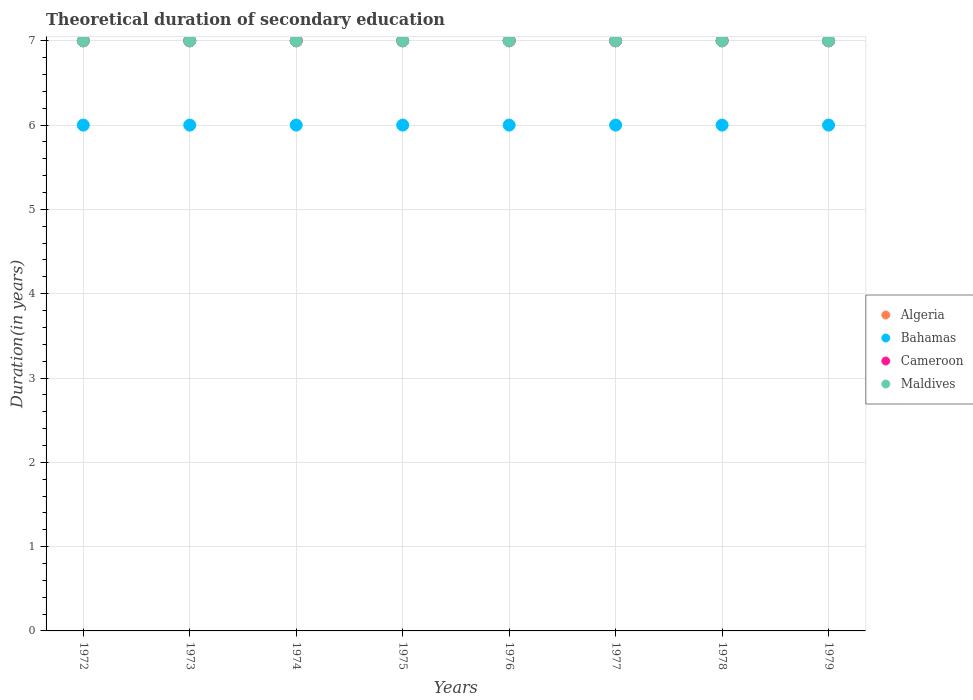How many different coloured dotlines are there?
Provide a short and direct response. 4. Is the number of dotlines equal to the number of legend labels?
Keep it short and to the point. Yes. What is the total theoretical duration of secondary education in Cameroon in 1975?
Offer a terse response. 7. Across all years, what is the maximum total theoretical duration of secondary education in Bahamas?
Offer a very short reply. 6. Across all years, what is the minimum total theoretical duration of secondary education in Cameroon?
Provide a short and direct response. 7. In which year was the total theoretical duration of secondary education in Algeria maximum?
Offer a terse response. 1972. In which year was the total theoretical duration of secondary education in Algeria minimum?
Provide a succinct answer. 1972. What is the total total theoretical duration of secondary education in Algeria in the graph?
Provide a short and direct response. 56. What is the difference between the total theoretical duration of secondary education in Cameroon in 1979 and the total theoretical duration of secondary education in Algeria in 1977?
Make the answer very short. 0. What is the average total theoretical duration of secondary education in Maldives per year?
Your response must be concise. 7. In the year 1979, what is the difference between the total theoretical duration of secondary education in Cameroon and total theoretical duration of secondary education in Maldives?
Make the answer very short. 0. In how many years, is the total theoretical duration of secondary education in Bahamas greater than 4.6 years?
Offer a very short reply. 8. What is the ratio of the total theoretical duration of secondary education in Cameroon in 1973 to that in 1979?
Your response must be concise. 1. Is the total theoretical duration of secondary education in Bahamas in 1973 less than that in 1976?
Your response must be concise. No. What is the difference between the highest and the second highest total theoretical duration of secondary education in Bahamas?
Your answer should be very brief. 0. What is the difference between the highest and the lowest total theoretical duration of secondary education in Bahamas?
Ensure brevity in your answer.  0. Is it the case that in every year, the sum of the total theoretical duration of secondary education in Bahamas and total theoretical duration of secondary education in Cameroon  is greater than the sum of total theoretical duration of secondary education in Maldives and total theoretical duration of secondary education in Algeria?
Make the answer very short. No. Does the total theoretical duration of secondary education in Maldives monotonically increase over the years?
Keep it short and to the point. No. How many dotlines are there?
Keep it short and to the point. 4. Does the graph contain grids?
Provide a succinct answer. Yes. Where does the legend appear in the graph?
Provide a short and direct response. Center right. How many legend labels are there?
Give a very brief answer. 4. How are the legend labels stacked?
Your answer should be compact. Vertical. What is the title of the graph?
Give a very brief answer. Theoretical duration of secondary education. What is the label or title of the Y-axis?
Your answer should be very brief. Duration(in years). What is the Duration(in years) in Bahamas in 1972?
Your answer should be compact. 6. What is the Duration(in years) of Cameroon in 1972?
Provide a succinct answer. 7. What is the Duration(in years) of Maldives in 1972?
Your answer should be very brief. 7. What is the Duration(in years) of Algeria in 1973?
Provide a short and direct response. 7. What is the Duration(in years) in Maldives in 1973?
Ensure brevity in your answer.  7. What is the Duration(in years) of Algeria in 1974?
Your answer should be compact. 7. What is the Duration(in years) in Bahamas in 1974?
Offer a very short reply. 6. What is the Duration(in years) in Maldives in 1974?
Your answer should be compact. 7. What is the Duration(in years) in Algeria in 1975?
Give a very brief answer. 7. What is the Duration(in years) of Cameroon in 1975?
Your response must be concise. 7. What is the Duration(in years) in Bahamas in 1976?
Give a very brief answer. 6. What is the Duration(in years) of Cameroon in 1976?
Give a very brief answer. 7. What is the Duration(in years) in Algeria in 1977?
Make the answer very short. 7. What is the Duration(in years) of Bahamas in 1977?
Offer a very short reply. 6. What is the Duration(in years) in Bahamas in 1978?
Give a very brief answer. 6. What is the Duration(in years) in Cameroon in 1978?
Provide a succinct answer. 7. What is the Duration(in years) in Algeria in 1979?
Keep it short and to the point. 7. What is the Duration(in years) in Bahamas in 1979?
Your response must be concise. 6. What is the Duration(in years) in Cameroon in 1979?
Make the answer very short. 7. What is the Duration(in years) of Maldives in 1979?
Ensure brevity in your answer.  7. Across all years, what is the maximum Duration(in years) in Algeria?
Provide a short and direct response. 7. Across all years, what is the maximum Duration(in years) of Bahamas?
Your answer should be very brief. 6. Across all years, what is the minimum Duration(in years) in Algeria?
Provide a succinct answer. 7. Across all years, what is the minimum Duration(in years) in Cameroon?
Provide a short and direct response. 7. What is the total Duration(in years) in Cameroon in the graph?
Your response must be concise. 56. What is the difference between the Duration(in years) in Algeria in 1972 and that in 1974?
Provide a succinct answer. 0. What is the difference between the Duration(in years) of Cameroon in 1972 and that in 1974?
Give a very brief answer. 0. What is the difference between the Duration(in years) in Maldives in 1972 and that in 1974?
Your answer should be compact. 0. What is the difference between the Duration(in years) in Algeria in 1972 and that in 1975?
Give a very brief answer. 0. What is the difference between the Duration(in years) of Cameroon in 1972 and that in 1975?
Offer a very short reply. 0. What is the difference between the Duration(in years) of Algeria in 1972 and that in 1976?
Provide a succinct answer. 0. What is the difference between the Duration(in years) in Cameroon in 1972 and that in 1976?
Ensure brevity in your answer.  0. What is the difference between the Duration(in years) of Maldives in 1972 and that in 1976?
Your answer should be compact. 0. What is the difference between the Duration(in years) in Algeria in 1972 and that in 1977?
Your answer should be compact. 0. What is the difference between the Duration(in years) of Cameroon in 1972 and that in 1977?
Give a very brief answer. 0. What is the difference between the Duration(in years) of Maldives in 1972 and that in 1977?
Ensure brevity in your answer.  0. What is the difference between the Duration(in years) of Cameroon in 1972 and that in 1978?
Give a very brief answer. 0. What is the difference between the Duration(in years) in Cameroon in 1972 and that in 1979?
Keep it short and to the point. 0. What is the difference between the Duration(in years) of Algeria in 1973 and that in 1974?
Offer a terse response. 0. What is the difference between the Duration(in years) in Maldives in 1973 and that in 1974?
Ensure brevity in your answer.  0. What is the difference between the Duration(in years) in Bahamas in 1973 and that in 1975?
Keep it short and to the point. 0. What is the difference between the Duration(in years) in Cameroon in 1973 and that in 1975?
Offer a very short reply. 0. What is the difference between the Duration(in years) in Algeria in 1973 and that in 1976?
Your answer should be very brief. 0. What is the difference between the Duration(in years) of Bahamas in 1973 and that in 1976?
Offer a terse response. 0. What is the difference between the Duration(in years) in Maldives in 1973 and that in 1976?
Keep it short and to the point. 0. What is the difference between the Duration(in years) of Algeria in 1973 and that in 1977?
Provide a short and direct response. 0. What is the difference between the Duration(in years) of Cameroon in 1973 and that in 1977?
Offer a terse response. 0. What is the difference between the Duration(in years) in Algeria in 1973 and that in 1978?
Give a very brief answer. 0. What is the difference between the Duration(in years) of Bahamas in 1973 and that in 1978?
Offer a terse response. 0. What is the difference between the Duration(in years) of Cameroon in 1973 and that in 1978?
Your answer should be compact. 0. What is the difference between the Duration(in years) in Maldives in 1973 and that in 1978?
Provide a succinct answer. 0. What is the difference between the Duration(in years) of Algeria in 1973 and that in 1979?
Provide a succinct answer. 0. What is the difference between the Duration(in years) of Bahamas in 1973 and that in 1979?
Your response must be concise. 0. What is the difference between the Duration(in years) of Cameroon in 1973 and that in 1979?
Your response must be concise. 0. What is the difference between the Duration(in years) of Maldives in 1973 and that in 1979?
Offer a very short reply. 0. What is the difference between the Duration(in years) in Algeria in 1974 and that in 1975?
Your response must be concise. 0. What is the difference between the Duration(in years) of Cameroon in 1974 and that in 1975?
Keep it short and to the point. 0. What is the difference between the Duration(in years) in Bahamas in 1974 and that in 1976?
Provide a succinct answer. 0. What is the difference between the Duration(in years) of Algeria in 1974 and that in 1977?
Give a very brief answer. 0. What is the difference between the Duration(in years) in Bahamas in 1974 and that in 1977?
Offer a terse response. 0. What is the difference between the Duration(in years) of Cameroon in 1974 and that in 1977?
Offer a terse response. 0. What is the difference between the Duration(in years) of Maldives in 1974 and that in 1977?
Make the answer very short. 0. What is the difference between the Duration(in years) of Algeria in 1974 and that in 1978?
Offer a very short reply. 0. What is the difference between the Duration(in years) in Bahamas in 1974 and that in 1978?
Make the answer very short. 0. What is the difference between the Duration(in years) in Cameroon in 1974 and that in 1978?
Offer a terse response. 0. What is the difference between the Duration(in years) of Maldives in 1974 and that in 1978?
Make the answer very short. 0. What is the difference between the Duration(in years) in Bahamas in 1974 and that in 1979?
Your answer should be very brief. 0. What is the difference between the Duration(in years) of Cameroon in 1975 and that in 1976?
Provide a short and direct response. 0. What is the difference between the Duration(in years) in Maldives in 1975 and that in 1976?
Make the answer very short. 0. What is the difference between the Duration(in years) in Algeria in 1975 and that in 1977?
Offer a terse response. 0. What is the difference between the Duration(in years) in Bahamas in 1975 and that in 1977?
Make the answer very short. 0. What is the difference between the Duration(in years) of Cameroon in 1975 and that in 1977?
Your answer should be very brief. 0. What is the difference between the Duration(in years) of Bahamas in 1975 and that in 1978?
Your response must be concise. 0. What is the difference between the Duration(in years) in Algeria in 1975 and that in 1979?
Provide a short and direct response. 0. What is the difference between the Duration(in years) in Cameroon in 1975 and that in 1979?
Your answer should be compact. 0. What is the difference between the Duration(in years) of Maldives in 1975 and that in 1979?
Offer a terse response. 0. What is the difference between the Duration(in years) of Algeria in 1976 and that in 1977?
Your answer should be compact. 0. What is the difference between the Duration(in years) in Bahamas in 1976 and that in 1977?
Your answer should be very brief. 0. What is the difference between the Duration(in years) in Maldives in 1976 and that in 1977?
Keep it short and to the point. 0. What is the difference between the Duration(in years) in Algeria in 1976 and that in 1978?
Provide a short and direct response. 0. What is the difference between the Duration(in years) of Bahamas in 1976 and that in 1978?
Provide a short and direct response. 0. What is the difference between the Duration(in years) in Maldives in 1976 and that in 1978?
Provide a short and direct response. 0. What is the difference between the Duration(in years) of Algeria in 1976 and that in 1979?
Offer a very short reply. 0. What is the difference between the Duration(in years) of Bahamas in 1977 and that in 1978?
Make the answer very short. 0. What is the difference between the Duration(in years) of Cameroon in 1977 and that in 1978?
Make the answer very short. 0. What is the difference between the Duration(in years) in Maldives in 1977 and that in 1978?
Ensure brevity in your answer.  0. What is the difference between the Duration(in years) of Algeria in 1977 and that in 1979?
Your response must be concise. 0. What is the difference between the Duration(in years) of Bahamas in 1977 and that in 1979?
Provide a short and direct response. 0. What is the difference between the Duration(in years) in Cameroon in 1977 and that in 1979?
Make the answer very short. 0. What is the difference between the Duration(in years) of Algeria in 1978 and that in 1979?
Your response must be concise. 0. What is the difference between the Duration(in years) of Bahamas in 1978 and that in 1979?
Offer a terse response. 0. What is the difference between the Duration(in years) in Cameroon in 1978 and that in 1979?
Your answer should be compact. 0. What is the difference between the Duration(in years) of Maldives in 1978 and that in 1979?
Offer a terse response. 0. What is the difference between the Duration(in years) of Algeria in 1972 and the Duration(in years) of Bahamas in 1973?
Provide a succinct answer. 1. What is the difference between the Duration(in years) of Bahamas in 1972 and the Duration(in years) of Cameroon in 1973?
Give a very brief answer. -1. What is the difference between the Duration(in years) in Bahamas in 1972 and the Duration(in years) in Maldives in 1973?
Your answer should be very brief. -1. What is the difference between the Duration(in years) of Cameroon in 1972 and the Duration(in years) of Maldives in 1973?
Make the answer very short. 0. What is the difference between the Duration(in years) of Algeria in 1972 and the Duration(in years) of Bahamas in 1974?
Keep it short and to the point. 1. What is the difference between the Duration(in years) in Algeria in 1972 and the Duration(in years) in Cameroon in 1974?
Ensure brevity in your answer.  0. What is the difference between the Duration(in years) in Bahamas in 1972 and the Duration(in years) in Cameroon in 1974?
Your response must be concise. -1. What is the difference between the Duration(in years) in Bahamas in 1972 and the Duration(in years) in Maldives in 1974?
Give a very brief answer. -1. What is the difference between the Duration(in years) in Cameroon in 1972 and the Duration(in years) in Maldives in 1974?
Provide a succinct answer. 0. What is the difference between the Duration(in years) in Algeria in 1972 and the Duration(in years) in Cameroon in 1975?
Your answer should be compact. 0. What is the difference between the Duration(in years) in Algeria in 1972 and the Duration(in years) in Bahamas in 1976?
Offer a very short reply. 1. What is the difference between the Duration(in years) of Algeria in 1972 and the Duration(in years) of Cameroon in 1976?
Your response must be concise. 0. What is the difference between the Duration(in years) of Bahamas in 1972 and the Duration(in years) of Cameroon in 1976?
Your response must be concise. -1. What is the difference between the Duration(in years) in Bahamas in 1972 and the Duration(in years) in Maldives in 1976?
Offer a terse response. -1. What is the difference between the Duration(in years) of Cameroon in 1972 and the Duration(in years) of Maldives in 1976?
Your response must be concise. 0. What is the difference between the Duration(in years) in Bahamas in 1972 and the Duration(in years) in Cameroon in 1977?
Make the answer very short. -1. What is the difference between the Duration(in years) in Bahamas in 1972 and the Duration(in years) in Maldives in 1977?
Provide a succinct answer. -1. What is the difference between the Duration(in years) in Cameroon in 1972 and the Duration(in years) in Maldives in 1977?
Ensure brevity in your answer.  0. What is the difference between the Duration(in years) in Algeria in 1972 and the Duration(in years) in Cameroon in 1978?
Provide a short and direct response. 0. What is the difference between the Duration(in years) of Algeria in 1972 and the Duration(in years) of Maldives in 1978?
Give a very brief answer. 0. What is the difference between the Duration(in years) of Bahamas in 1972 and the Duration(in years) of Cameroon in 1978?
Your answer should be compact. -1. What is the difference between the Duration(in years) of Bahamas in 1972 and the Duration(in years) of Maldives in 1978?
Make the answer very short. -1. What is the difference between the Duration(in years) in Algeria in 1973 and the Duration(in years) in Bahamas in 1974?
Your answer should be very brief. 1. What is the difference between the Duration(in years) in Algeria in 1973 and the Duration(in years) in Maldives in 1974?
Offer a very short reply. 0. What is the difference between the Duration(in years) in Bahamas in 1973 and the Duration(in years) in Cameroon in 1974?
Offer a terse response. -1. What is the difference between the Duration(in years) in Cameroon in 1973 and the Duration(in years) in Maldives in 1974?
Offer a very short reply. 0. What is the difference between the Duration(in years) of Bahamas in 1973 and the Duration(in years) of Cameroon in 1975?
Offer a very short reply. -1. What is the difference between the Duration(in years) of Bahamas in 1973 and the Duration(in years) of Maldives in 1975?
Make the answer very short. -1. What is the difference between the Duration(in years) in Cameroon in 1973 and the Duration(in years) in Maldives in 1975?
Keep it short and to the point. 0. What is the difference between the Duration(in years) of Algeria in 1973 and the Duration(in years) of Bahamas in 1976?
Your response must be concise. 1. What is the difference between the Duration(in years) in Bahamas in 1973 and the Duration(in years) in Cameroon in 1976?
Ensure brevity in your answer.  -1. What is the difference between the Duration(in years) of Algeria in 1973 and the Duration(in years) of Bahamas in 1977?
Offer a very short reply. 1. What is the difference between the Duration(in years) in Bahamas in 1973 and the Duration(in years) in Cameroon in 1977?
Ensure brevity in your answer.  -1. What is the difference between the Duration(in years) in Bahamas in 1973 and the Duration(in years) in Maldives in 1977?
Offer a terse response. -1. What is the difference between the Duration(in years) of Algeria in 1973 and the Duration(in years) of Maldives in 1978?
Offer a terse response. 0. What is the difference between the Duration(in years) in Bahamas in 1973 and the Duration(in years) in Cameroon in 1979?
Your answer should be very brief. -1. What is the difference between the Duration(in years) of Bahamas in 1973 and the Duration(in years) of Maldives in 1979?
Your response must be concise. -1. What is the difference between the Duration(in years) in Cameroon in 1973 and the Duration(in years) in Maldives in 1979?
Keep it short and to the point. 0. What is the difference between the Duration(in years) of Algeria in 1974 and the Duration(in years) of Cameroon in 1975?
Make the answer very short. 0. What is the difference between the Duration(in years) in Algeria in 1974 and the Duration(in years) in Maldives in 1975?
Provide a succinct answer. 0. What is the difference between the Duration(in years) in Bahamas in 1974 and the Duration(in years) in Cameroon in 1975?
Provide a short and direct response. -1. What is the difference between the Duration(in years) of Cameroon in 1974 and the Duration(in years) of Maldives in 1975?
Ensure brevity in your answer.  0. What is the difference between the Duration(in years) of Algeria in 1974 and the Duration(in years) of Cameroon in 1976?
Provide a short and direct response. 0. What is the difference between the Duration(in years) in Bahamas in 1974 and the Duration(in years) in Maldives in 1976?
Provide a succinct answer. -1. What is the difference between the Duration(in years) in Cameroon in 1974 and the Duration(in years) in Maldives in 1976?
Provide a succinct answer. 0. What is the difference between the Duration(in years) in Algeria in 1974 and the Duration(in years) in Maldives in 1977?
Keep it short and to the point. 0. What is the difference between the Duration(in years) in Algeria in 1974 and the Duration(in years) in Bahamas in 1978?
Your answer should be very brief. 1. What is the difference between the Duration(in years) of Bahamas in 1974 and the Duration(in years) of Cameroon in 1978?
Provide a succinct answer. -1. What is the difference between the Duration(in years) in Bahamas in 1974 and the Duration(in years) in Maldives in 1978?
Provide a succinct answer. -1. What is the difference between the Duration(in years) in Algeria in 1974 and the Duration(in years) in Bahamas in 1979?
Give a very brief answer. 1. What is the difference between the Duration(in years) in Algeria in 1974 and the Duration(in years) in Maldives in 1979?
Your answer should be compact. 0. What is the difference between the Duration(in years) of Bahamas in 1974 and the Duration(in years) of Cameroon in 1979?
Offer a terse response. -1. What is the difference between the Duration(in years) of Algeria in 1975 and the Duration(in years) of Maldives in 1976?
Make the answer very short. 0. What is the difference between the Duration(in years) in Bahamas in 1975 and the Duration(in years) in Maldives in 1976?
Keep it short and to the point. -1. What is the difference between the Duration(in years) in Algeria in 1975 and the Duration(in years) in Cameroon in 1977?
Ensure brevity in your answer.  0. What is the difference between the Duration(in years) of Algeria in 1975 and the Duration(in years) of Cameroon in 1978?
Make the answer very short. 0. What is the difference between the Duration(in years) of Bahamas in 1975 and the Duration(in years) of Cameroon in 1978?
Make the answer very short. -1. What is the difference between the Duration(in years) in Algeria in 1975 and the Duration(in years) in Cameroon in 1979?
Provide a short and direct response. 0. What is the difference between the Duration(in years) of Algeria in 1975 and the Duration(in years) of Maldives in 1979?
Provide a succinct answer. 0. What is the difference between the Duration(in years) in Bahamas in 1975 and the Duration(in years) in Maldives in 1979?
Make the answer very short. -1. What is the difference between the Duration(in years) in Algeria in 1976 and the Duration(in years) in Cameroon in 1977?
Provide a short and direct response. 0. What is the difference between the Duration(in years) of Bahamas in 1976 and the Duration(in years) of Maldives in 1977?
Keep it short and to the point. -1. What is the difference between the Duration(in years) of Bahamas in 1976 and the Duration(in years) of Cameroon in 1978?
Make the answer very short. -1. What is the difference between the Duration(in years) in Bahamas in 1976 and the Duration(in years) in Maldives in 1979?
Give a very brief answer. -1. What is the difference between the Duration(in years) in Algeria in 1977 and the Duration(in years) in Maldives in 1978?
Ensure brevity in your answer.  0. What is the difference between the Duration(in years) of Bahamas in 1977 and the Duration(in years) of Maldives in 1978?
Ensure brevity in your answer.  -1. What is the difference between the Duration(in years) in Cameroon in 1977 and the Duration(in years) in Maldives in 1978?
Your answer should be compact. 0. What is the difference between the Duration(in years) in Algeria in 1977 and the Duration(in years) in Bahamas in 1979?
Provide a succinct answer. 1. What is the difference between the Duration(in years) in Bahamas in 1977 and the Duration(in years) in Cameroon in 1979?
Provide a succinct answer. -1. What is the difference between the Duration(in years) of Cameroon in 1977 and the Duration(in years) of Maldives in 1979?
Provide a short and direct response. 0. What is the difference between the Duration(in years) in Bahamas in 1978 and the Duration(in years) in Maldives in 1979?
Your answer should be very brief. -1. What is the difference between the Duration(in years) in Cameroon in 1978 and the Duration(in years) in Maldives in 1979?
Offer a terse response. 0. What is the average Duration(in years) in Algeria per year?
Offer a very short reply. 7. What is the average Duration(in years) in Maldives per year?
Your answer should be very brief. 7. In the year 1972, what is the difference between the Duration(in years) of Algeria and Duration(in years) of Bahamas?
Your answer should be very brief. 1. In the year 1972, what is the difference between the Duration(in years) in Algeria and Duration(in years) in Cameroon?
Give a very brief answer. 0. In the year 1972, what is the difference between the Duration(in years) of Algeria and Duration(in years) of Maldives?
Your answer should be very brief. 0. In the year 1972, what is the difference between the Duration(in years) in Bahamas and Duration(in years) in Cameroon?
Your answer should be very brief. -1. In the year 1972, what is the difference between the Duration(in years) in Bahamas and Duration(in years) in Maldives?
Offer a terse response. -1. In the year 1973, what is the difference between the Duration(in years) in Algeria and Duration(in years) in Bahamas?
Offer a terse response. 1. In the year 1973, what is the difference between the Duration(in years) of Algeria and Duration(in years) of Cameroon?
Offer a terse response. 0. In the year 1973, what is the difference between the Duration(in years) of Bahamas and Duration(in years) of Maldives?
Your answer should be compact. -1. In the year 1973, what is the difference between the Duration(in years) of Cameroon and Duration(in years) of Maldives?
Keep it short and to the point. 0. In the year 1974, what is the difference between the Duration(in years) of Algeria and Duration(in years) of Cameroon?
Provide a succinct answer. 0. In the year 1974, what is the difference between the Duration(in years) in Algeria and Duration(in years) in Maldives?
Provide a short and direct response. 0. In the year 1974, what is the difference between the Duration(in years) in Bahamas and Duration(in years) in Maldives?
Make the answer very short. -1. In the year 1975, what is the difference between the Duration(in years) of Algeria and Duration(in years) of Bahamas?
Ensure brevity in your answer.  1. In the year 1975, what is the difference between the Duration(in years) in Algeria and Duration(in years) in Maldives?
Provide a short and direct response. 0. In the year 1975, what is the difference between the Duration(in years) in Cameroon and Duration(in years) in Maldives?
Your response must be concise. 0. In the year 1976, what is the difference between the Duration(in years) in Algeria and Duration(in years) in Bahamas?
Provide a short and direct response. 1. In the year 1976, what is the difference between the Duration(in years) of Algeria and Duration(in years) of Maldives?
Give a very brief answer. 0. In the year 1977, what is the difference between the Duration(in years) of Algeria and Duration(in years) of Bahamas?
Make the answer very short. 1. In the year 1977, what is the difference between the Duration(in years) of Bahamas and Duration(in years) of Cameroon?
Offer a terse response. -1. In the year 1977, what is the difference between the Duration(in years) in Bahamas and Duration(in years) in Maldives?
Your answer should be very brief. -1. In the year 1977, what is the difference between the Duration(in years) of Cameroon and Duration(in years) of Maldives?
Keep it short and to the point. 0. In the year 1978, what is the difference between the Duration(in years) of Algeria and Duration(in years) of Bahamas?
Ensure brevity in your answer.  1. In the year 1978, what is the difference between the Duration(in years) in Algeria and Duration(in years) in Cameroon?
Give a very brief answer. 0. In the year 1978, what is the difference between the Duration(in years) of Algeria and Duration(in years) of Maldives?
Offer a terse response. 0. In the year 1978, what is the difference between the Duration(in years) of Bahamas and Duration(in years) of Cameroon?
Keep it short and to the point. -1. In the year 1979, what is the difference between the Duration(in years) in Algeria and Duration(in years) in Cameroon?
Make the answer very short. 0. In the year 1979, what is the difference between the Duration(in years) in Algeria and Duration(in years) in Maldives?
Your response must be concise. 0. What is the ratio of the Duration(in years) of Cameroon in 1972 to that in 1973?
Your answer should be compact. 1. What is the ratio of the Duration(in years) of Algeria in 1972 to that in 1975?
Ensure brevity in your answer.  1. What is the ratio of the Duration(in years) of Algeria in 1972 to that in 1976?
Make the answer very short. 1. What is the ratio of the Duration(in years) in Bahamas in 1972 to that in 1976?
Your answer should be compact. 1. What is the ratio of the Duration(in years) of Bahamas in 1972 to that in 1977?
Your answer should be compact. 1. What is the ratio of the Duration(in years) in Maldives in 1972 to that in 1977?
Provide a succinct answer. 1. What is the ratio of the Duration(in years) of Bahamas in 1972 to that in 1978?
Provide a short and direct response. 1. What is the ratio of the Duration(in years) of Algeria in 1972 to that in 1979?
Make the answer very short. 1. What is the ratio of the Duration(in years) in Algeria in 1973 to that in 1974?
Make the answer very short. 1. What is the ratio of the Duration(in years) in Bahamas in 1973 to that in 1974?
Give a very brief answer. 1. What is the ratio of the Duration(in years) in Maldives in 1973 to that in 1974?
Keep it short and to the point. 1. What is the ratio of the Duration(in years) in Cameroon in 1973 to that in 1975?
Offer a terse response. 1. What is the ratio of the Duration(in years) of Maldives in 1973 to that in 1975?
Your answer should be compact. 1. What is the ratio of the Duration(in years) in Algeria in 1973 to that in 1976?
Provide a succinct answer. 1. What is the ratio of the Duration(in years) in Maldives in 1973 to that in 1976?
Your response must be concise. 1. What is the ratio of the Duration(in years) of Algeria in 1973 to that in 1977?
Offer a terse response. 1. What is the ratio of the Duration(in years) of Bahamas in 1973 to that in 1977?
Give a very brief answer. 1. What is the ratio of the Duration(in years) of Maldives in 1973 to that in 1977?
Provide a succinct answer. 1. What is the ratio of the Duration(in years) of Bahamas in 1973 to that in 1978?
Your answer should be compact. 1. What is the ratio of the Duration(in years) in Maldives in 1973 to that in 1978?
Your answer should be very brief. 1. What is the ratio of the Duration(in years) of Cameroon in 1973 to that in 1979?
Your answer should be very brief. 1. What is the ratio of the Duration(in years) of Maldives in 1973 to that in 1979?
Provide a succinct answer. 1. What is the ratio of the Duration(in years) in Bahamas in 1974 to that in 1975?
Your answer should be compact. 1. What is the ratio of the Duration(in years) in Cameroon in 1974 to that in 1975?
Your response must be concise. 1. What is the ratio of the Duration(in years) in Maldives in 1974 to that in 1975?
Give a very brief answer. 1. What is the ratio of the Duration(in years) in Cameroon in 1974 to that in 1976?
Give a very brief answer. 1. What is the ratio of the Duration(in years) in Algeria in 1974 to that in 1977?
Ensure brevity in your answer.  1. What is the ratio of the Duration(in years) in Maldives in 1974 to that in 1977?
Offer a terse response. 1. What is the ratio of the Duration(in years) in Algeria in 1974 to that in 1978?
Offer a very short reply. 1. What is the ratio of the Duration(in years) of Bahamas in 1974 to that in 1978?
Offer a very short reply. 1. What is the ratio of the Duration(in years) of Cameroon in 1974 to that in 1978?
Your answer should be very brief. 1. What is the ratio of the Duration(in years) of Bahamas in 1974 to that in 1979?
Keep it short and to the point. 1. What is the ratio of the Duration(in years) of Maldives in 1974 to that in 1979?
Give a very brief answer. 1. What is the ratio of the Duration(in years) of Bahamas in 1975 to that in 1976?
Give a very brief answer. 1. What is the ratio of the Duration(in years) in Cameroon in 1975 to that in 1976?
Make the answer very short. 1. What is the ratio of the Duration(in years) in Maldives in 1975 to that in 1976?
Your response must be concise. 1. What is the ratio of the Duration(in years) of Algeria in 1975 to that in 1977?
Provide a short and direct response. 1. What is the ratio of the Duration(in years) in Bahamas in 1975 to that in 1977?
Give a very brief answer. 1. What is the ratio of the Duration(in years) in Cameroon in 1975 to that in 1977?
Your answer should be very brief. 1. What is the ratio of the Duration(in years) of Bahamas in 1975 to that in 1978?
Offer a terse response. 1. What is the ratio of the Duration(in years) in Maldives in 1975 to that in 1978?
Provide a short and direct response. 1. What is the ratio of the Duration(in years) of Cameroon in 1975 to that in 1979?
Keep it short and to the point. 1. What is the ratio of the Duration(in years) in Cameroon in 1976 to that in 1977?
Your answer should be very brief. 1. What is the ratio of the Duration(in years) in Maldives in 1976 to that in 1977?
Give a very brief answer. 1. What is the ratio of the Duration(in years) in Algeria in 1976 to that in 1978?
Your answer should be compact. 1. What is the ratio of the Duration(in years) in Algeria in 1976 to that in 1979?
Ensure brevity in your answer.  1. What is the ratio of the Duration(in years) of Bahamas in 1977 to that in 1979?
Ensure brevity in your answer.  1. What is the ratio of the Duration(in years) of Cameroon in 1977 to that in 1979?
Offer a very short reply. 1. What is the ratio of the Duration(in years) in Bahamas in 1978 to that in 1979?
Your answer should be compact. 1. What is the ratio of the Duration(in years) of Cameroon in 1978 to that in 1979?
Offer a very short reply. 1. What is the difference between the highest and the second highest Duration(in years) of Algeria?
Offer a very short reply. 0. What is the difference between the highest and the lowest Duration(in years) of Bahamas?
Provide a short and direct response. 0. What is the difference between the highest and the lowest Duration(in years) in Cameroon?
Your answer should be compact. 0. 